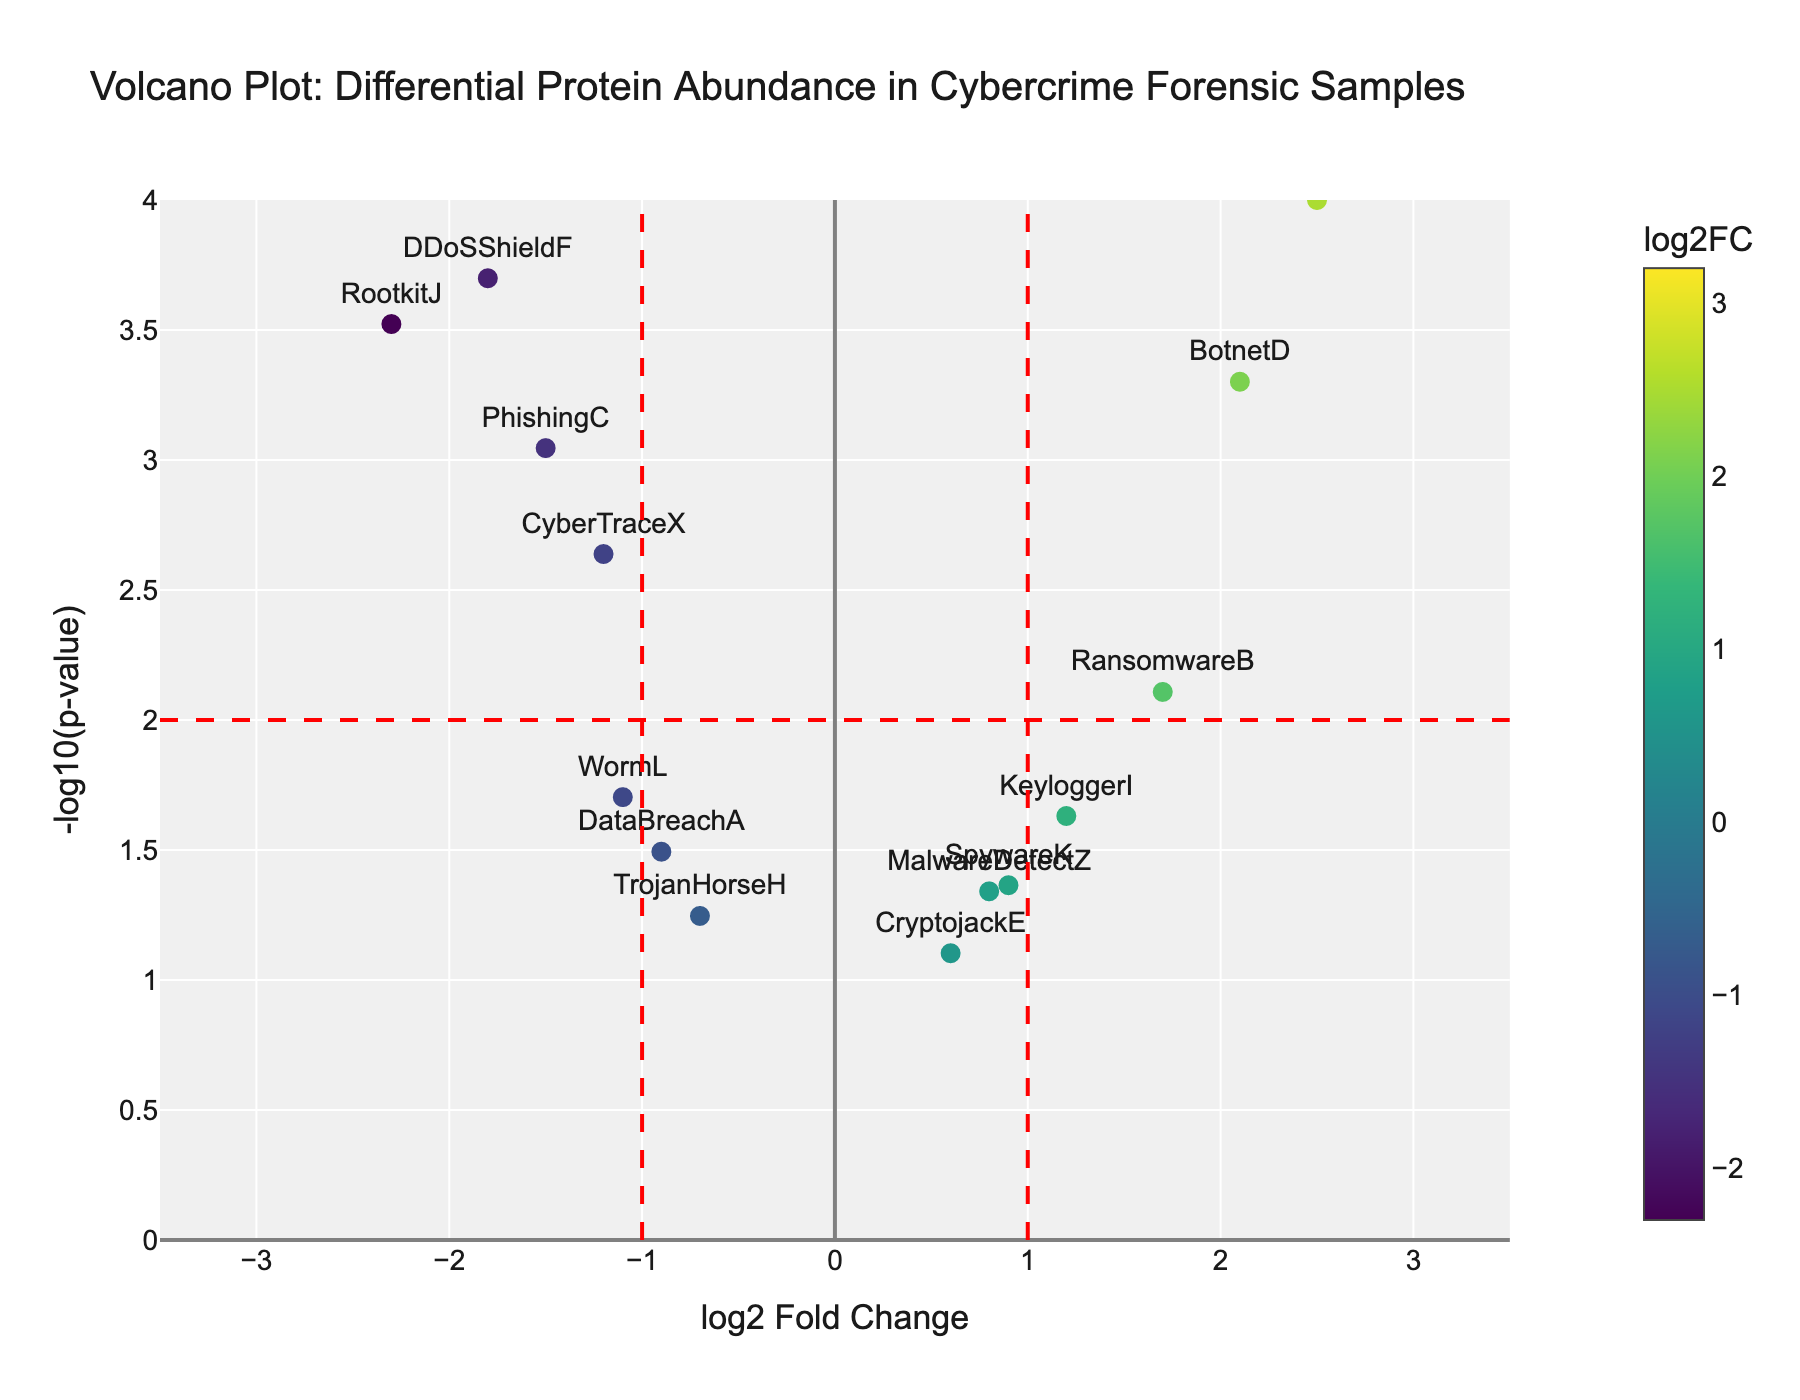What's the title of the figure? The title of a figure is typically written at the top and summarizes the main focus of the visualization. For this figure, it is "Volcano Plot: Differential Protein Abundance in Cybercrime Forensic Samples".
Answer: Volcano Plot: Differential Protein Abundance in Cybercrime Forensic Samples How many proteins show significant differential abundance with a p-value less than 0.01? To identify proteins with a p-value less than 0.01, you can look at the y-axis representing -log10(p-value). A p-value of 0.01 corresponds to a -log10(p-value) of 2. From the figure, these proteins are: CyberTraceX, NetForensicY, PhishingC, BotnetD, DDoSShieldF, ZeroDay-G, and RootkitJ.
Answer: 7 proteins Which protein has the highest log2 fold change? The highest log2 fold change is represented by the highest value on the x-axis. From the figure, ZeroDay-G has the highest value with a log2FC of 3.2.
Answer: ZeroDay-G What is the log2 fold change and significance (p-value) of RansomwareB? By locating the data point labeled RansomwareB on the plot, we see that it has a log2 fold change of 1.7 and a p-value represented by a -log10(p-value) of slightly above 2. The exact values are log2FC 1.7 and p-value 0.0078.
Answer: log2FC: 1.7, p-value: 0.0078 How many proteins have a log2 fold change less than -1? A log2 fold change less than -1 corresponds to points on the left side of the vertical line at x = -1. Proteins satisfying this are DDoSShieldF, PhishingC, WormL, and RootkitJ.
Answer: 4 proteins Compare the significance of NetForensicY and BotnetD. Which one is more significant? The significance is determined by the -log10(p-value), with higher values indicating higher significance. NetForensicY has a -log10(p-value) of approximately 4 (p = 0.0001) and BotnetD also around 3.3 (p = 0.0005). Therefore, NetForensicY is more significant.
Answer: NetForensicY Which proteins have a positive log2 fold change greater than 2 and are significant (p-value < 0.01)? Proteins with a log2 fold change greater than 2 appear on the right side of the vertical line at x = 2, and with a p-value < 0.01, they should also be above y = 2. The proteins satisfying these conditions are NetForensicY and ZeroDay-G.
Answer: NetForensicY, ZeroDay-G Compare the protein abundance of MalwareDetectZ and SpywareK. Which one has a higher log2 fold change? The log2 fold change is represented by the x-axis. MalwareDetectZ has a log2FC of 0.8, while SpywareK has a log2FC of 0.9. Thus, SpywareK has a higher log2 fold change.
Answer: SpywareK How many proteins have a -log10(p-value) greater than 2? Proteins with a -log10(p-value) greater than 2 are positioned above y = 2. From the plot, these proteins are CyberTraceX, NetForensicY, PhishingC, BotnetD, DDoSShieldF, ZeroDay-G, RansomwareB, and RootkitJ.
Answer: 8 proteins 